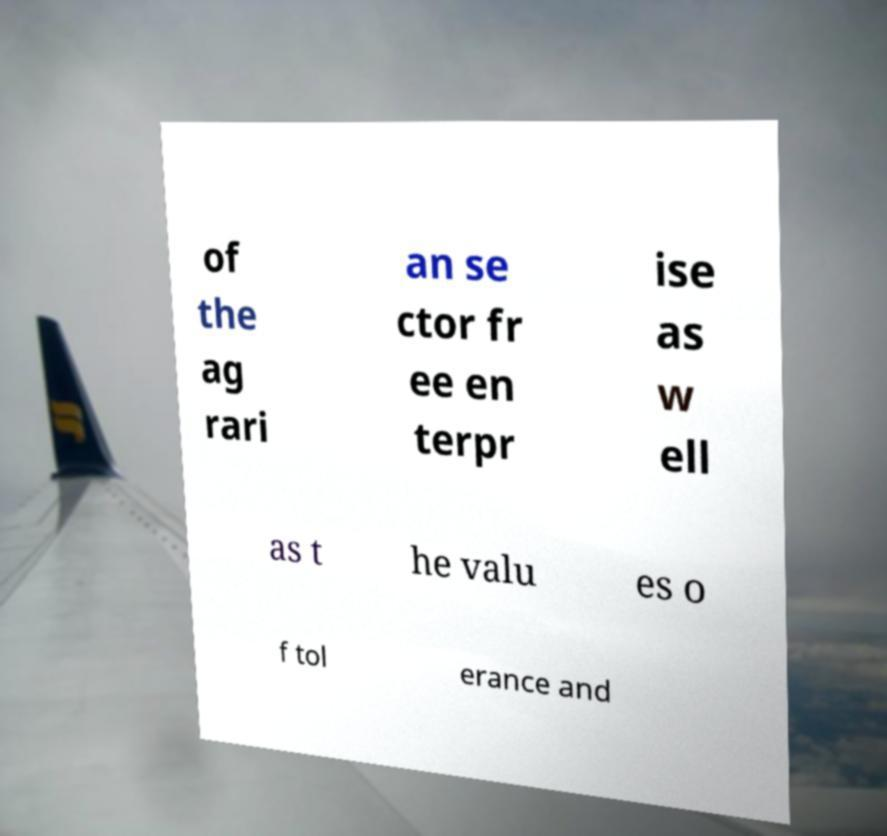There's text embedded in this image that I need extracted. Can you transcribe it verbatim? of the ag rari an se ctor fr ee en terpr ise as w ell as t he valu es o f tol erance and 